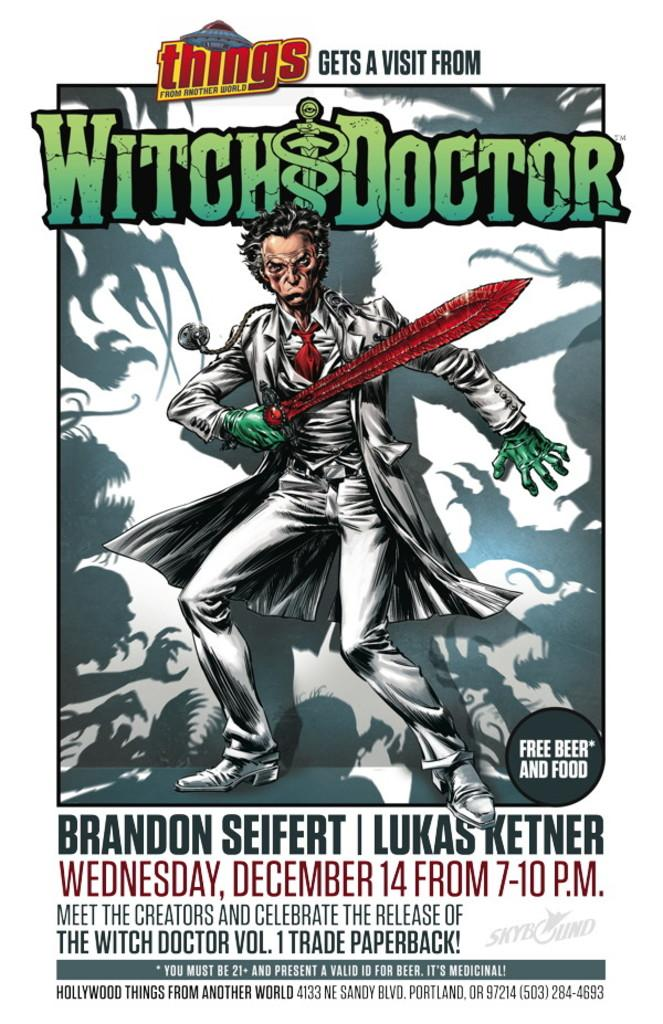<image>
Provide a brief description of the given image. A poster about an event celebrating the release of The Witch Doctor Vol. 1. 